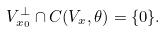<formula> <loc_0><loc_0><loc_500><loc_500>V _ { x _ { 0 } } ^ { \bot } \cap C ( V _ { x } , \theta ) = \{ 0 \} .</formula> 